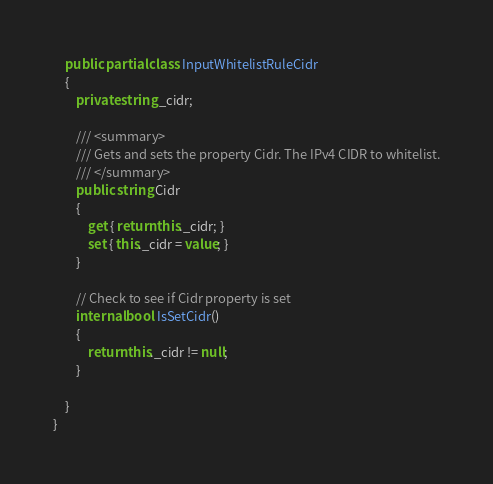<code> <loc_0><loc_0><loc_500><loc_500><_C#_>    public partial class InputWhitelistRuleCidr
    {
        private string _cidr;

        /// <summary>
        /// Gets and sets the property Cidr. The IPv4 CIDR to whitelist.
        /// </summary>
        public string Cidr
        {
            get { return this._cidr; }
            set { this._cidr = value; }
        }

        // Check to see if Cidr property is set
        internal bool IsSetCidr()
        {
            return this._cidr != null;
        }

    }
}</code> 